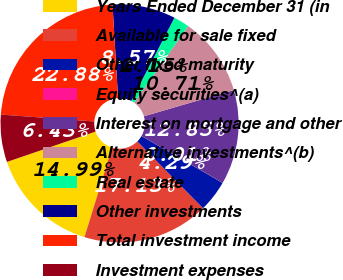<chart> <loc_0><loc_0><loc_500><loc_500><pie_chart><fcel>Years Ended December 31 (in<fcel>Available for sale fixed<fcel>Other fixed maturity<fcel>Equity securities^(a)<fcel>Interest on mortgage and other<fcel>Alternative investments^(b)<fcel>Real estate<fcel>Other investments<fcel>Total investment income<fcel>Investment expenses<nl><fcel>14.99%<fcel>17.13%<fcel>4.29%<fcel>0.01%<fcel>12.85%<fcel>10.71%<fcel>2.15%<fcel>8.57%<fcel>22.88%<fcel>6.43%<nl></chart> 